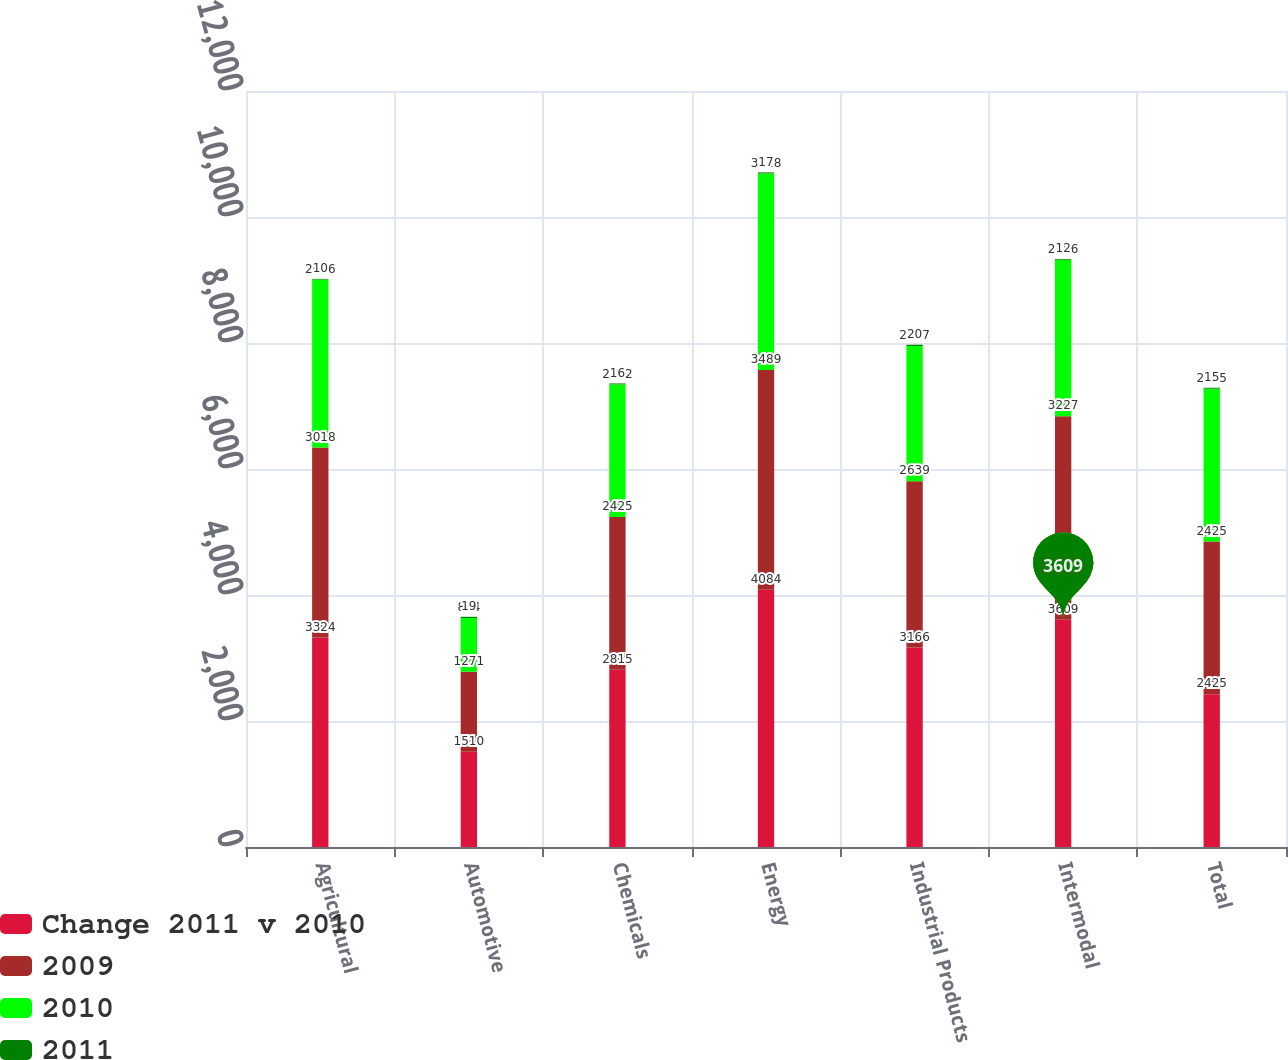Convert chart to OTSL. <chart><loc_0><loc_0><loc_500><loc_500><stacked_bar_chart><ecel><fcel>Agricultural<fcel>Automotive<fcel>Chemicals<fcel>Energy<fcel>Industrial Products<fcel>Intermodal<fcel>Total<nl><fcel>Change 2011 v 2010<fcel>3324<fcel>1510<fcel>2815<fcel>4084<fcel>3166<fcel>3609<fcel>2425<nl><fcel>2009<fcel>3018<fcel>1271<fcel>2425<fcel>3489<fcel>2639<fcel>3227<fcel>2425<nl><fcel>2010<fcel>2666<fcel>854<fcel>2102<fcel>3118<fcel>2147<fcel>2486<fcel>2425<nl><fcel>2011<fcel>10<fcel>19<fcel>16<fcel>17<fcel>20<fcel>12<fcel>15<nl></chart> 